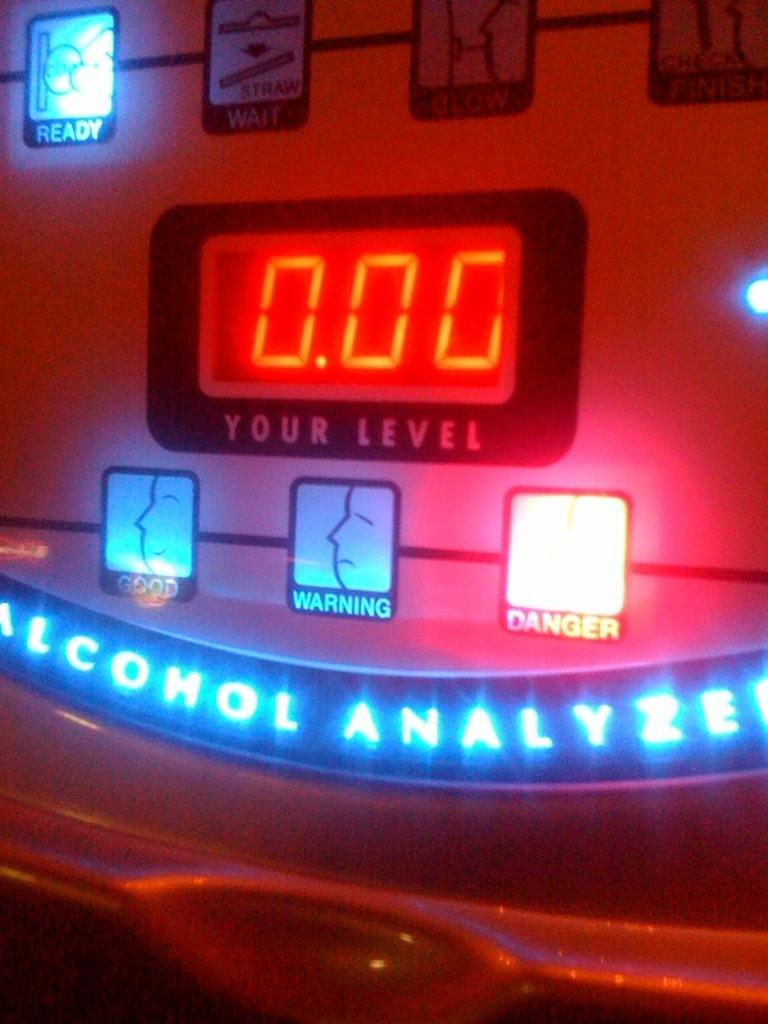Provide a one-sentence caption for the provided image. a machine that is an alcahol analyzer that tells your level. 